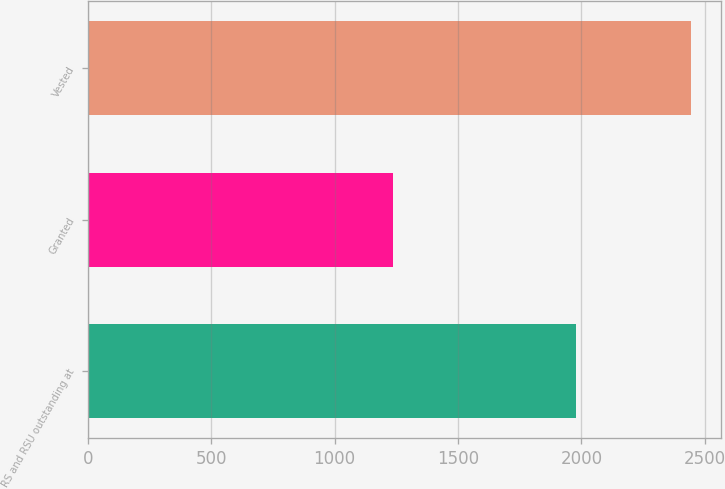Convert chart. <chart><loc_0><loc_0><loc_500><loc_500><bar_chart><fcel>RS and RSU outstanding at<fcel>Granted<fcel>Vested<nl><fcel>1979<fcel>1235<fcel>2445<nl></chart> 